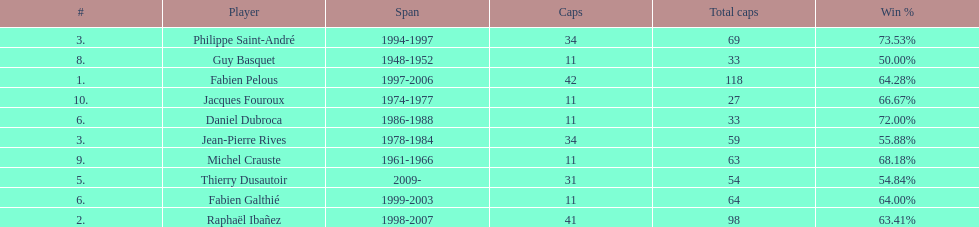Only player to serve as captain from 1998-2007 Raphaël Ibañez. 